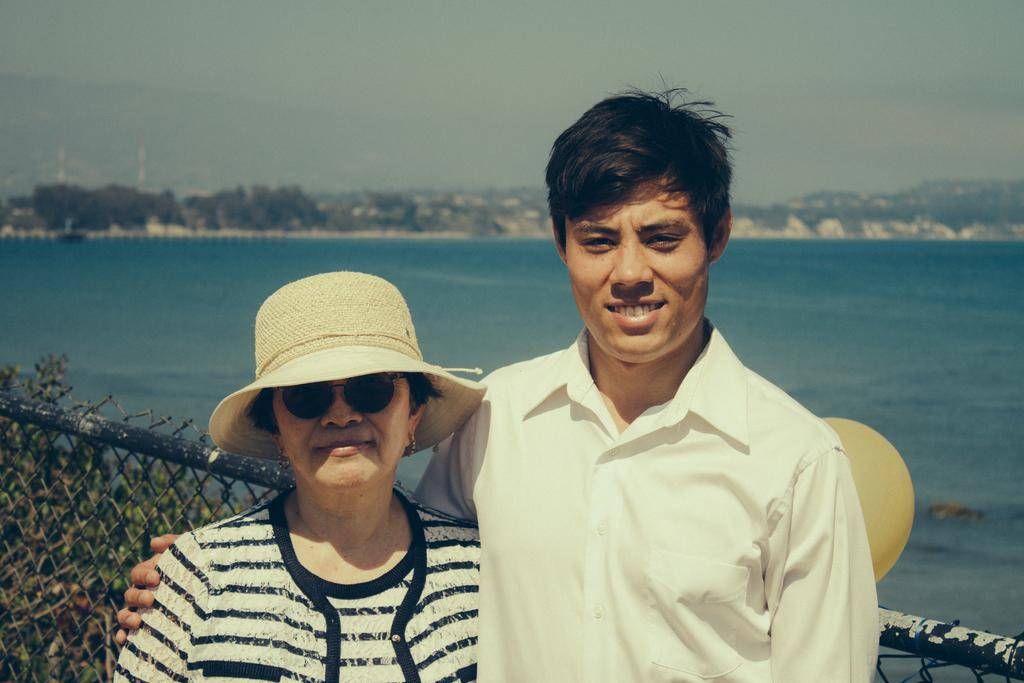How many people are in the image? There are two persons standing in the image. What is the facial expression of the persons? The persons are smiling. What is located behind the persons? There is a railing behind the persons. What can be seen in the distance in the image? There is a river, mountains, and the sky visible in the background of the image. What type of coat is the person wearing in the image? There is no coat visible in the image; the persons are not wearing any outerwear. Why is the person crying in the image? There is no person crying in the image; both persons are smiling. 